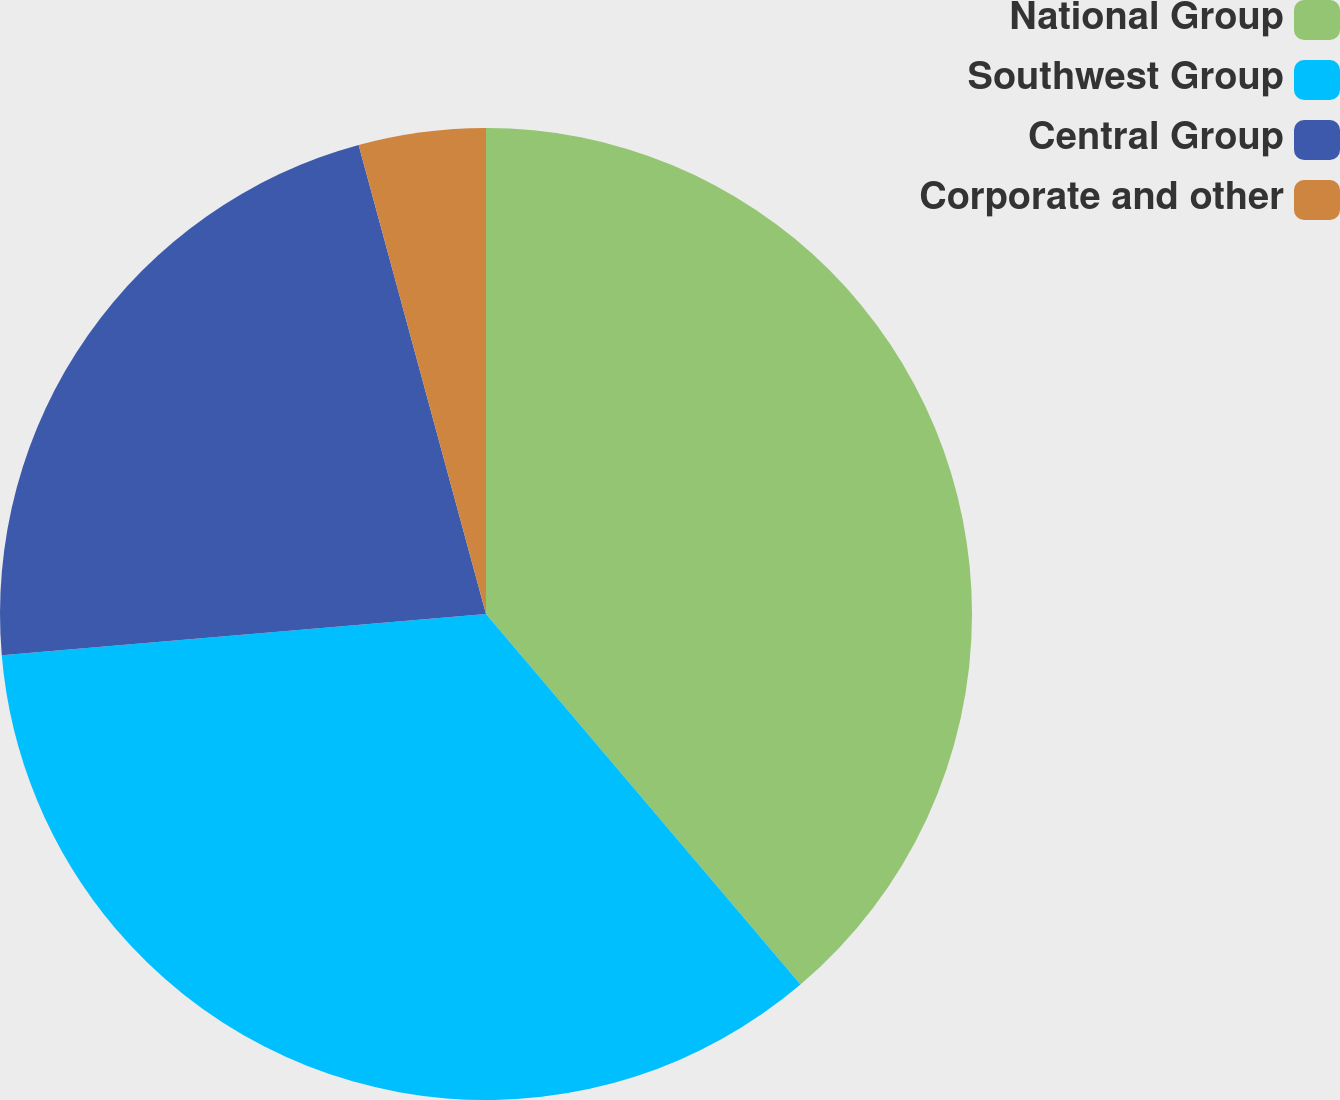Convert chart. <chart><loc_0><loc_0><loc_500><loc_500><pie_chart><fcel>National Group<fcel>Southwest Group<fcel>Central Group<fcel>Corporate and other<nl><fcel>38.8%<fcel>34.85%<fcel>22.13%<fcel>4.22%<nl></chart> 